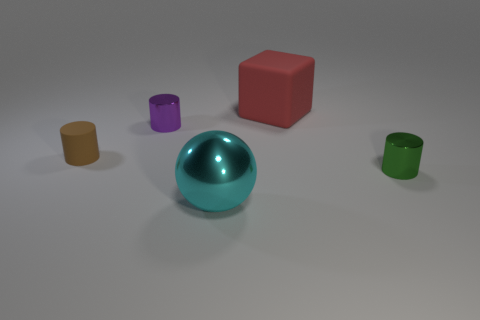Add 4 large blue metal blocks. How many objects exist? 9 Subtract all blocks. How many objects are left? 4 Subtract 0 red balls. How many objects are left? 5 Subtract all red metallic cubes. Subtract all large spheres. How many objects are left? 4 Add 4 big cyan metal objects. How many big cyan metal objects are left? 5 Add 3 small blue cylinders. How many small blue cylinders exist? 3 